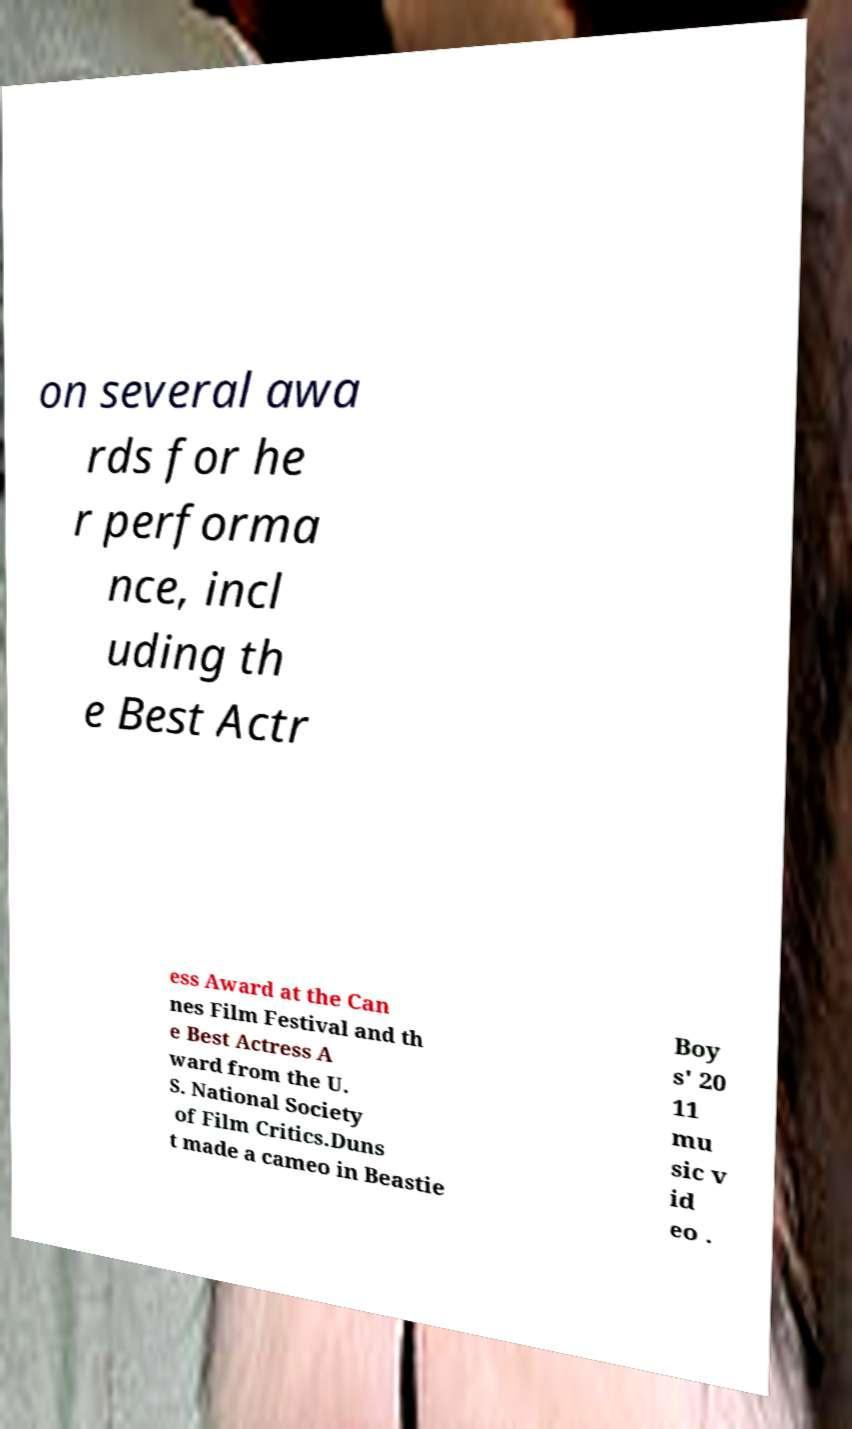There's text embedded in this image that I need extracted. Can you transcribe it verbatim? on several awa rds for he r performa nce, incl uding th e Best Actr ess Award at the Can nes Film Festival and th e Best Actress A ward from the U. S. National Society of Film Critics.Duns t made a cameo in Beastie Boy s' 20 11 mu sic v id eo . 